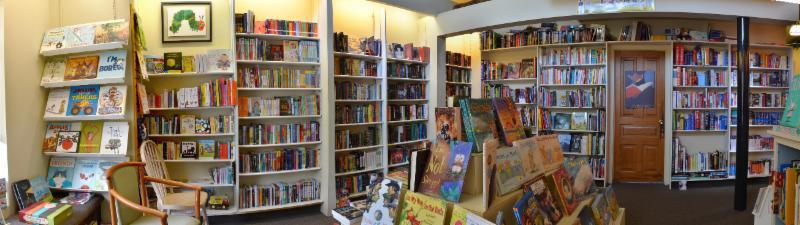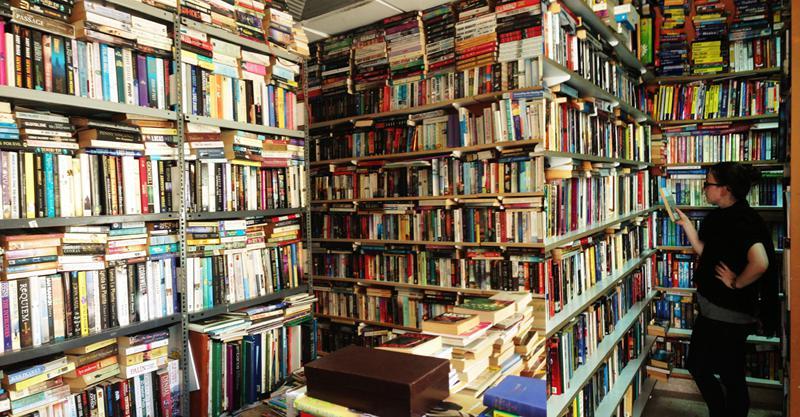The first image is the image on the left, the second image is the image on the right. Assess this claim about the two images: "The right image features one woman with a bag slung on her back, standing with her back to the camera and facing leftward toward a solid wall of books on shelves.". Correct or not? Answer yes or no. No. 